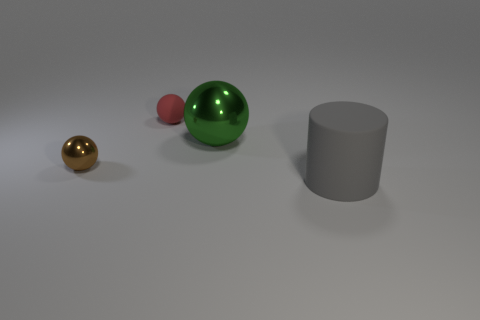How many brown things are small shiny things or big things?
Your answer should be very brief. 1. There is a matte object that is behind the metallic ball in front of the big object to the left of the cylinder; what is its shape?
Offer a terse response. Sphere. The matte cylinder that is the same size as the green metal ball is what color?
Offer a terse response. Gray. What number of other matte objects have the same shape as the gray thing?
Offer a very short reply. 0. There is a brown object; is it the same size as the rubber object left of the large gray object?
Provide a succinct answer. Yes. What is the shape of the matte thing that is to the right of the tiny sphere behind the tiny metal ball?
Give a very brief answer. Cylinder. Are there fewer green things behind the big rubber object than tiny gray cubes?
Offer a very short reply. No. How many other shiny things have the same size as the brown shiny object?
Keep it short and to the point. 0. The green metal thing in front of the small rubber sphere has what shape?
Provide a succinct answer. Sphere. Is the number of tiny brown shiny balls less than the number of brown shiny cubes?
Your answer should be compact. No. 